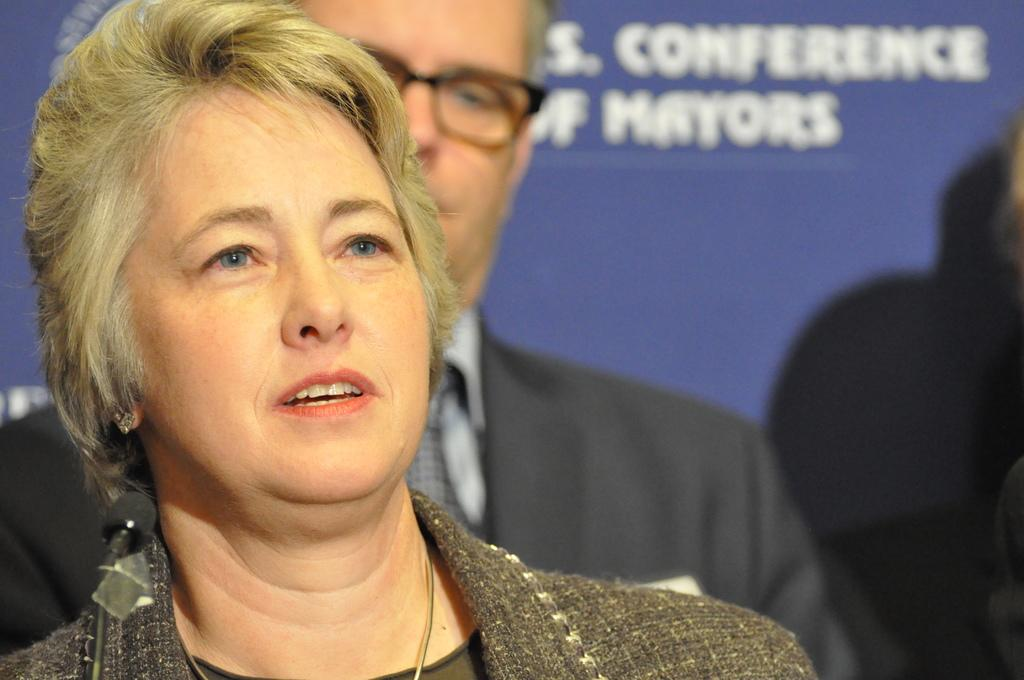How many people are in the image? There are two people in the image, a woman and a man. What are the positions of the woman and the man in the image? Both the woman and the man are standing in the image. What can be seen in the background of the image? There is a banner in the image. What is written on the banner? The banner has text on it. What type of cart is being pulled by the woman in the image? There is no cart present in the image; the woman is simply standing. What is the woman using to listen to the man's thoughts in the image? There is no indication in the image that the woman is trying to listen to the man's thoughts or using any device to do so. 